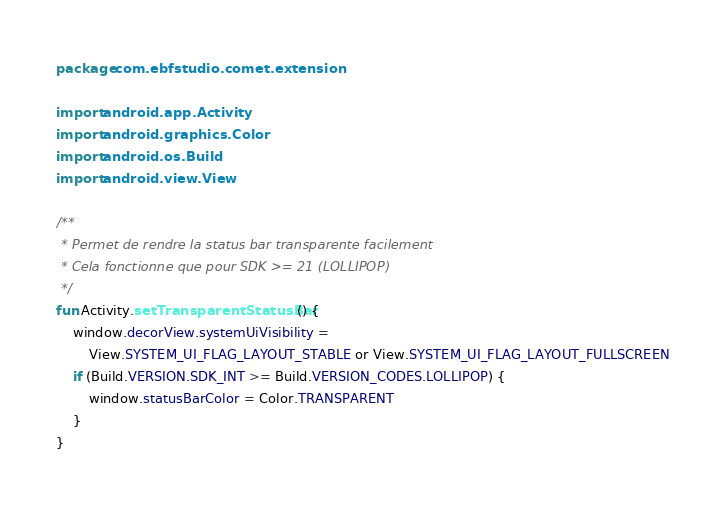Convert code to text. <code><loc_0><loc_0><loc_500><loc_500><_Kotlin_>package com.ebfstudio.comet.extension

import android.app.Activity
import android.graphics.Color
import android.os.Build
import android.view.View

/**
 * Permet de rendre la status bar transparente facilement
 * Cela fonctionne que pour SDK >= 21 (LOLLIPOP)
 */
fun Activity.setTransparentStatusBar() {
    window.decorView.systemUiVisibility =
        View.SYSTEM_UI_FLAG_LAYOUT_STABLE or View.SYSTEM_UI_FLAG_LAYOUT_FULLSCREEN
    if (Build.VERSION.SDK_INT >= Build.VERSION_CODES.LOLLIPOP) {
        window.statusBarColor = Color.TRANSPARENT
    }
}</code> 